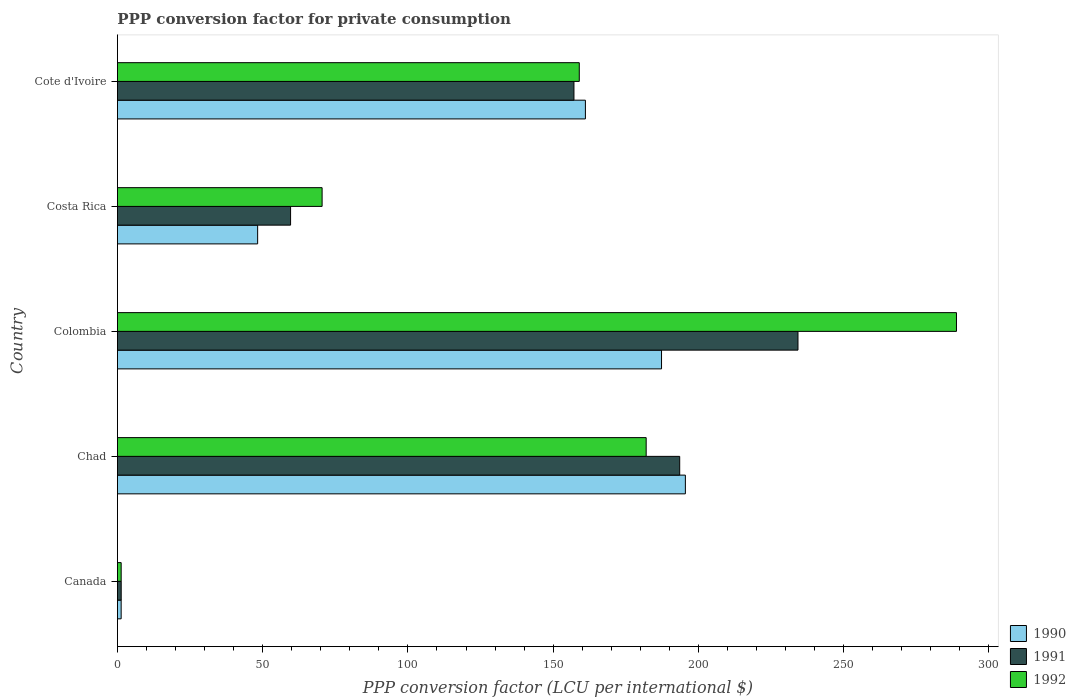How many different coloured bars are there?
Offer a terse response. 3. How many groups of bars are there?
Your response must be concise. 5. Are the number of bars per tick equal to the number of legend labels?
Offer a very short reply. Yes. Are the number of bars on each tick of the Y-axis equal?
Make the answer very short. Yes. How many bars are there on the 3rd tick from the top?
Make the answer very short. 3. What is the label of the 4th group of bars from the top?
Ensure brevity in your answer.  Chad. In how many cases, is the number of bars for a given country not equal to the number of legend labels?
Your response must be concise. 0. What is the PPP conversion factor for private consumption in 1990 in Costa Rica?
Your response must be concise. 48.27. Across all countries, what is the maximum PPP conversion factor for private consumption in 1990?
Offer a very short reply. 195.5. Across all countries, what is the minimum PPP conversion factor for private consumption in 1992?
Offer a very short reply. 1.3. In which country was the PPP conversion factor for private consumption in 1990 maximum?
Provide a short and direct response. Chad. What is the total PPP conversion factor for private consumption in 1990 in the graph?
Provide a short and direct response. 593.45. What is the difference between the PPP conversion factor for private consumption in 1992 in Canada and that in Costa Rica?
Give a very brief answer. -69.16. What is the difference between the PPP conversion factor for private consumption in 1992 in Costa Rica and the PPP conversion factor for private consumption in 1991 in Colombia?
Your response must be concise. -163.8. What is the average PPP conversion factor for private consumption in 1991 per country?
Your answer should be compact. 129.17. What is the difference between the PPP conversion factor for private consumption in 1991 and PPP conversion factor for private consumption in 1990 in Canada?
Your response must be concise. 0.02. In how many countries, is the PPP conversion factor for private consumption in 1991 greater than 130 LCU?
Provide a succinct answer. 3. What is the ratio of the PPP conversion factor for private consumption in 1992 in Chad to that in Colombia?
Offer a terse response. 0.63. What is the difference between the highest and the second highest PPP conversion factor for private consumption in 1991?
Provide a succinct answer. 40.71. What is the difference between the highest and the lowest PPP conversion factor for private consumption in 1992?
Provide a succinct answer. 287.52. In how many countries, is the PPP conversion factor for private consumption in 1991 greater than the average PPP conversion factor for private consumption in 1991 taken over all countries?
Your answer should be compact. 3. What does the 2nd bar from the top in Chad represents?
Offer a very short reply. 1991. What does the 3rd bar from the bottom in Canada represents?
Keep it short and to the point. 1992. Is it the case that in every country, the sum of the PPP conversion factor for private consumption in 1992 and PPP conversion factor for private consumption in 1990 is greater than the PPP conversion factor for private consumption in 1991?
Make the answer very short. Yes. What is the difference between two consecutive major ticks on the X-axis?
Provide a short and direct response. 50. Are the values on the major ticks of X-axis written in scientific E-notation?
Provide a succinct answer. No. Does the graph contain any zero values?
Your answer should be compact. No. How many legend labels are there?
Give a very brief answer. 3. What is the title of the graph?
Provide a succinct answer. PPP conversion factor for private consumption. What is the label or title of the X-axis?
Provide a short and direct response. PPP conversion factor (LCU per international $). What is the PPP conversion factor (LCU per international $) in 1990 in Canada?
Give a very brief answer. 1.29. What is the PPP conversion factor (LCU per international $) of 1991 in Canada?
Make the answer very short. 1.31. What is the PPP conversion factor (LCU per international $) in 1992 in Canada?
Provide a succinct answer. 1.3. What is the PPP conversion factor (LCU per international $) of 1990 in Chad?
Provide a short and direct response. 195.5. What is the PPP conversion factor (LCU per international $) of 1991 in Chad?
Offer a terse response. 193.55. What is the PPP conversion factor (LCU per international $) in 1992 in Chad?
Provide a short and direct response. 182.01. What is the PPP conversion factor (LCU per international $) in 1990 in Colombia?
Give a very brief answer. 187.29. What is the PPP conversion factor (LCU per international $) in 1991 in Colombia?
Your response must be concise. 234.26. What is the PPP conversion factor (LCU per international $) of 1992 in Colombia?
Offer a terse response. 288.82. What is the PPP conversion factor (LCU per international $) of 1990 in Costa Rica?
Make the answer very short. 48.27. What is the PPP conversion factor (LCU per international $) of 1991 in Costa Rica?
Offer a terse response. 59.61. What is the PPP conversion factor (LCU per international $) in 1992 in Costa Rica?
Offer a terse response. 70.46. What is the PPP conversion factor (LCU per international $) of 1990 in Cote d'Ivoire?
Provide a succinct answer. 161.09. What is the PPP conversion factor (LCU per international $) in 1991 in Cote d'Ivoire?
Offer a terse response. 157.15. What is the PPP conversion factor (LCU per international $) of 1992 in Cote d'Ivoire?
Provide a short and direct response. 158.98. Across all countries, what is the maximum PPP conversion factor (LCU per international $) in 1990?
Offer a very short reply. 195.5. Across all countries, what is the maximum PPP conversion factor (LCU per international $) in 1991?
Offer a terse response. 234.26. Across all countries, what is the maximum PPP conversion factor (LCU per international $) of 1992?
Keep it short and to the point. 288.82. Across all countries, what is the minimum PPP conversion factor (LCU per international $) of 1990?
Offer a very short reply. 1.29. Across all countries, what is the minimum PPP conversion factor (LCU per international $) in 1991?
Give a very brief answer. 1.31. Across all countries, what is the minimum PPP conversion factor (LCU per international $) in 1992?
Your answer should be very brief. 1.3. What is the total PPP conversion factor (LCU per international $) in 1990 in the graph?
Give a very brief answer. 593.45. What is the total PPP conversion factor (LCU per international $) of 1991 in the graph?
Your answer should be compact. 645.87. What is the total PPP conversion factor (LCU per international $) in 1992 in the graph?
Your answer should be compact. 701.56. What is the difference between the PPP conversion factor (LCU per international $) in 1990 in Canada and that in Chad?
Offer a terse response. -194.21. What is the difference between the PPP conversion factor (LCU per international $) in 1991 in Canada and that in Chad?
Your response must be concise. -192.24. What is the difference between the PPP conversion factor (LCU per international $) in 1992 in Canada and that in Chad?
Your answer should be compact. -180.71. What is the difference between the PPP conversion factor (LCU per international $) in 1990 in Canada and that in Colombia?
Your answer should be compact. -186. What is the difference between the PPP conversion factor (LCU per international $) in 1991 in Canada and that in Colombia?
Keep it short and to the point. -232.95. What is the difference between the PPP conversion factor (LCU per international $) in 1992 in Canada and that in Colombia?
Make the answer very short. -287.52. What is the difference between the PPP conversion factor (LCU per international $) in 1990 in Canada and that in Costa Rica?
Ensure brevity in your answer.  -46.98. What is the difference between the PPP conversion factor (LCU per international $) in 1991 in Canada and that in Costa Rica?
Keep it short and to the point. -58.3. What is the difference between the PPP conversion factor (LCU per international $) of 1992 in Canada and that in Costa Rica?
Your answer should be very brief. -69.16. What is the difference between the PPP conversion factor (LCU per international $) of 1990 in Canada and that in Cote d'Ivoire?
Offer a very short reply. -159.8. What is the difference between the PPP conversion factor (LCU per international $) in 1991 in Canada and that in Cote d'Ivoire?
Your response must be concise. -155.84. What is the difference between the PPP conversion factor (LCU per international $) of 1992 in Canada and that in Cote d'Ivoire?
Give a very brief answer. -157.69. What is the difference between the PPP conversion factor (LCU per international $) in 1990 in Chad and that in Colombia?
Your answer should be compact. 8.21. What is the difference between the PPP conversion factor (LCU per international $) of 1991 in Chad and that in Colombia?
Offer a terse response. -40.71. What is the difference between the PPP conversion factor (LCU per international $) of 1992 in Chad and that in Colombia?
Keep it short and to the point. -106.81. What is the difference between the PPP conversion factor (LCU per international $) of 1990 in Chad and that in Costa Rica?
Provide a short and direct response. 147.23. What is the difference between the PPP conversion factor (LCU per international $) in 1991 in Chad and that in Costa Rica?
Give a very brief answer. 133.94. What is the difference between the PPP conversion factor (LCU per international $) in 1992 in Chad and that in Costa Rica?
Make the answer very short. 111.55. What is the difference between the PPP conversion factor (LCU per international $) in 1990 in Chad and that in Cote d'Ivoire?
Your answer should be very brief. 34.41. What is the difference between the PPP conversion factor (LCU per international $) in 1991 in Chad and that in Cote d'Ivoire?
Provide a short and direct response. 36.4. What is the difference between the PPP conversion factor (LCU per international $) in 1992 in Chad and that in Cote d'Ivoire?
Provide a short and direct response. 23.03. What is the difference between the PPP conversion factor (LCU per international $) of 1990 in Colombia and that in Costa Rica?
Make the answer very short. 139.02. What is the difference between the PPP conversion factor (LCU per international $) in 1991 in Colombia and that in Costa Rica?
Offer a terse response. 174.65. What is the difference between the PPP conversion factor (LCU per international $) in 1992 in Colombia and that in Costa Rica?
Your response must be concise. 218.36. What is the difference between the PPP conversion factor (LCU per international $) in 1990 in Colombia and that in Cote d'Ivoire?
Offer a very short reply. 26.2. What is the difference between the PPP conversion factor (LCU per international $) in 1991 in Colombia and that in Cote d'Ivoire?
Your response must be concise. 77.11. What is the difference between the PPP conversion factor (LCU per international $) of 1992 in Colombia and that in Cote d'Ivoire?
Provide a short and direct response. 129.83. What is the difference between the PPP conversion factor (LCU per international $) of 1990 in Costa Rica and that in Cote d'Ivoire?
Your response must be concise. -112.82. What is the difference between the PPP conversion factor (LCU per international $) of 1991 in Costa Rica and that in Cote d'Ivoire?
Offer a very short reply. -97.54. What is the difference between the PPP conversion factor (LCU per international $) of 1992 in Costa Rica and that in Cote d'Ivoire?
Offer a very short reply. -88.52. What is the difference between the PPP conversion factor (LCU per international $) of 1990 in Canada and the PPP conversion factor (LCU per international $) of 1991 in Chad?
Offer a terse response. -192.26. What is the difference between the PPP conversion factor (LCU per international $) of 1990 in Canada and the PPP conversion factor (LCU per international $) of 1992 in Chad?
Your response must be concise. -180.72. What is the difference between the PPP conversion factor (LCU per international $) in 1991 in Canada and the PPP conversion factor (LCU per international $) in 1992 in Chad?
Provide a short and direct response. -180.7. What is the difference between the PPP conversion factor (LCU per international $) of 1990 in Canada and the PPP conversion factor (LCU per international $) of 1991 in Colombia?
Give a very brief answer. -232.97. What is the difference between the PPP conversion factor (LCU per international $) of 1990 in Canada and the PPP conversion factor (LCU per international $) of 1992 in Colombia?
Offer a terse response. -287.52. What is the difference between the PPP conversion factor (LCU per international $) of 1991 in Canada and the PPP conversion factor (LCU per international $) of 1992 in Colombia?
Your answer should be very brief. -287.51. What is the difference between the PPP conversion factor (LCU per international $) of 1990 in Canada and the PPP conversion factor (LCU per international $) of 1991 in Costa Rica?
Make the answer very short. -58.32. What is the difference between the PPP conversion factor (LCU per international $) of 1990 in Canada and the PPP conversion factor (LCU per international $) of 1992 in Costa Rica?
Your answer should be compact. -69.17. What is the difference between the PPP conversion factor (LCU per international $) in 1991 in Canada and the PPP conversion factor (LCU per international $) in 1992 in Costa Rica?
Provide a succinct answer. -69.15. What is the difference between the PPP conversion factor (LCU per international $) in 1990 in Canada and the PPP conversion factor (LCU per international $) in 1991 in Cote d'Ivoire?
Your answer should be compact. -155.86. What is the difference between the PPP conversion factor (LCU per international $) of 1990 in Canada and the PPP conversion factor (LCU per international $) of 1992 in Cote d'Ivoire?
Offer a very short reply. -157.69. What is the difference between the PPP conversion factor (LCU per international $) in 1991 in Canada and the PPP conversion factor (LCU per international $) in 1992 in Cote d'Ivoire?
Give a very brief answer. -157.67. What is the difference between the PPP conversion factor (LCU per international $) in 1990 in Chad and the PPP conversion factor (LCU per international $) in 1991 in Colombia?
Provide a succinct answer. -38.76. What is the difference between the PPP conversion factor (LCU per international $) of 1990 in Chad and the PPP conversion factor (LCU per international $) of 1992 in Colombia?
Offer a very short reply. -93.32. What is the difference between the PPP conversion factor (LCU per international $) of 1991 in Chad and the PPP conversion factor (LCU per international $) of 1992 in Colombia?
Your answer should be very brief. -95.27. What is the difference between the PPP conversion factor (LCU per international $) of 1990 in Chad and the PPP conversion factor (LCU per international $) of 1991 in Costa Rica?
Offer a terse response. 135.89. What is the difference between the PPP conversion factor (LCU per international $) in 1990 in Chad and the PPP conversion factor (LCU per international $) in 1992 in Costa Rica?
Provide a short and direct response. 125.04. What is the difference between the PPP conversion factor (LCU per international $) of 1991 in Chad and the PPP conversion factor (LCU per international $) of 1992 in Costa Rica?
Provide a short and direct response. 123.09. What is the difference between the PPP conversion factor (LCU per international $) in 1990 in Chad and the PPP conversion factor (LCU per international $) in 1991 in Cote d'Ivoire?
Your answer should be very brief. 38.35. What is the difference between the PPP conversion factor (LCU per international $) of 1990 in Chad and the PPP conversion factor (LCU per international $) of 1992 in Cote d'Ivoire?
Give a very brief answer. 36.52. What is the difference between the PPP conversion factor (LCU per international $) of 1991 in Chad and the PPP conversion factor (LCU per international $) of 1992 in Cote d'Ivoire?
Your response must be concise. 34.56. What is the difference between the PPP conversion factor (LCU per international $) of 1990 in Colombia and the PPP conversion factor (LCU per international $) of 1991 in Costa Rica?
Provide a succinct answer. 127.69. What is the difference between the PPP conversion factor (LCU per international $) in 1990 in Colombia and the PPP conversion factor (LCU per international $) in 1992 in Costa Rica?
Your response must be concise. 116.83. What is the difference between the PPP conversion factor (LCU per international $) of 1991 in Colombia and the PPP conversion factor (LCU per international $) of 1992 in Costa Rica?
Give a very brief answer. 163.8. What is the difference between the PPP conversion factor (LCU per international $) in 1990 in Colombia and the PPP conversion factor (LCU per international $) in 1991 in Cote d'Ivoire?
Offer a terse response. 30.15. What is the difference between the PPP conversion factor (LCU per international $) of 1990 in Colombia and the PPP conversion factor (LCU per international $) of 1992 in Cote d'Ivoire?
Keep it short and to the point. 28.31. What is the difference between the PPP conversion factor (LCU per international $) of 1991 in Colombia and the PPP conversion factor (LCU per international $) of 1992 in Cote d'Ivoire?
Keep it short and to the point. 75.28. What is the difference between the PPP conversion factor (LCU per international $) in 1990 in Costa Rica and the PPP conversion factor (LCU per international $) in 1991 in Cote d'Ivoire?
Offer a terse response. -108.88. What is the difference between the PPP conversion factor (LCU per international $) of 1990 in Costa Rica and the PPP conversion factor (LCU per international $) of 1992 in Cote d'Ivoire?
Offer a terse response. -110.71. What is the difference between the PPP conversion factor (LCU per international $) in 1991 in Costa Rica and the PPP conversion factor (LCU per international $) in 1992 in Cote d'Ivoire?
Your answer should be compact. -99.38. What is the average PPP conversion factor (LCU per international $) of 1990 per country?
Give a very brief answer. 118.69. What is the average PPP conversion factor (LCU per international $) of 1991 per country?
Your answer should be very brief. 129.17. What is the average PPP conversion factor (LCU per international $) in 1992 per country?
Keep it short and to the point. 140.31. What is the difference between the PPP conversion factor (LCU per international $) of 1990 and PPP conversion factor (LCU per international $) of 1991 in Canada?
Provide a succinct answer. -0.02. What is the difference between the PPP conversion factor (LCU per international $) in 1990 and PPP conversion factor (LCU per international $) in 1992 in Canada?
Ensure brevity in your answer.  -0.01. What is the difference between the PPP conversion factor (LCU per international $) of 1991 and PPP conversion factor (LCU per international $) of 1992 in Canada?
Give a very brief answer. 0.01. What is the difference between the PPP conversion factor (LCU per international $) in 1990 and PPP conversion factor (LCU per international $) in 1991 in Chad?
Provide a succinct answer. 1.95. What is the difference between the PPP conversion factor (LCU per international $) of 1990 and PPP conversion factor (LCU per international $) of 1992 in Chad?
Your response must be concise. 13.49. What is the difference between the PPP conversion factor (LCU per international $) in 1991 and PPP conversion factor (LCU per international $) in 1992 in Chad?
Keep it short and to the point. 11.54. What is the difference between the PPP conversion factor (LCU per international $) in 1990 and PPP conversion factor (LCU per international $) in 1991 in Colombia?
Offer a terse response. -46.97. What is the difference between the PPP conversion factor (LCU per international $) in 1990 and PPP conversion factor (LCU per international $) in 1992 in Colombia?
Your response must be concise. -101.52. What is the difference between the PPP conversion factor (LCU per international $) of 1991 and PPP conversion factor (LCU per international $) of 1992 in Colombia?
Keep it short and to the point. -54.56. What is the difference between the PPP conversion factor (LCU per international $) in 1990 and PPP conversion factor (LCU per international $) in 1991 in Costa Rica?
Offer a terse response. -11.33. What is the difference between the PPP conversion factor (LCU per international $) of 1990 and PPP conversion factor (LCU per international $) of 1992 in Costa Rica?
Offer a very short reply. -22.19. What is the difference between the PPP conversion factor (LCU per international $) in 1991 and PPP conversion factor (LCU per international $) in 1992 in Costa Rica?
Provide a short and direct response. -10.85. What is the difference between the PPP conversion factor (LCU per international $) of 1990 and PPP conversion factor (LCU per international $) of 1991 in Cote d'Ivoire?
Offer a very short reply. 3.94. What is the difference between the PPP conversion factor (LCU per international $) in 1990 and PPP conversion factor (LCU per international $) in 1992 in Cote d'Ivoire?
Your response must be concise. 2.11. What is the difference between the PPP conversion factor (LCU per international $) in 1991 and PPP conversion factor (LCU per international $) in 1992 in Cote d'Ivoire?
Your response must be concise. -1.83. What is the ratio of the PPP conversion factor (LCU per international $) of 1990 in Canada to that in Chad?
Keep it short and to the point. 0.01. What is the ratio of the PPP conversion factor (LCU per international $) of 1991 in Canada to that in Chad?
Keep it short and to the point. 0.01. What is the ratio of the PPP conversion factor (LCU per international $) in 1992 in Canada to that in Chad?
Give a very brief answer. 0.01. What is the ratio of the PPP conversion factor (LCU per international $) of 1990 in Canada to that in Colombia?
Your response must be concise. 0.01. What is the ratio of the PPP conversion factor (LCU per international $) in 1991 in Canada to that in Colombia?
Provide a short and direct response. 0.01. What is the ratio of the PPP conversion factor (LCU per international $) in 1992 in Canada to that in Colombia?
Ensure brevity in your answer.  0. What is the ratio of the PPP conversion factor (LCU per international $) in 1990 in Canada to that in Costa Rica?
Give a very brief answer. 0.03. What is the ratio of the PPP conversion factor (LCU per international $) of 1991 in Canada to that in Costa Rica?
Provide a short and direct response. 0.02. What is the ratio of the PPP conversion factor (LCU per international $) in 1992 in Canada to that in Costa Rica?
Provide a succinct answer. 0.02. What is the ratio of the PPP conversion factor (LCU per international $) in 1990 in Canada to that in Cote d'Ivoire?
Your response must be concise. 0.01. What is the ratio of the PPP conversion factor (LCU per international $) of 1991 in Canada to that in Cote d'Ivoire?
Make the answer very short. 0.01. What is the ratio of the PPP conversion factor (LCU per international $) of 1992 in Canada to that in Cote d'Ivoire?
Ensure brevity in your answer.  0.01. What is the ratio of the PPP conversion factor (LCU per international $) of 1990 in Chad to that in Colombia?
Your answer should be compact. 1.04. What is the ratio of the PPP conversion factor (LCU per international $) of 1991 in Chad to that in Colombia?
Provide a succinct answer. 0.83. What is the ratio of the PPP conversion factor (LCU per international $) of 1992 in Chad to that in Colombia?
Provide a short and direct response. 0.63. What is the ratio of the PPP conversion factor (LCU per international $) in 1990 in Chad to that in Costa Rica?
Give a very brief answer. 4.05. What is the ratio of the PPP conversion factor (LCU per international $) of 1991 in Chad to that in Costa Rica?
Provide a short and direct response. 3.25. What is the ratio of the PPP conversion factor (LCU per international $) in 1992 in Chad to that in Costa Rica?
Offer a very short reply. 2.58. What is the ratio of the PPP conversion factor (LCU per international $) in 1990 in Chad to that in Cote d'Ivoire?
Provide a succinct answer. 1.21. What is the ratio of the PPP conversion factor (LCU per international $) in 1991 in Chad to that in Cote d'Ivoire?
Offer a very short reply. 1.23. What is the ratio of the PPP conversion factor (LCU per international $) in 1992 in Chad to that in Cote d'Ivoire?
Offer a very short reply. 1.14. What is the ratio of the PPP conversion factor (LCU per international $) of 1990 in Colombia to that in Costa Rica?
Your answer should be compact. 3.88. What is the ratio of the PPP conversion factor (LCU per international $) in 1991 in Colombia to that in Costa Rica?
Your answer should be compact. 3.93. What is the ratio of the PPP conversion factor (LCU per international $) in 1992 in Colombia to that in Costa Rica?
Your answer should be very brief. 4.1. What is the ratio of the PPP conversion factor (LCU per international $) in 1990 in Colombia to that in Cote d'Ivoire?
Give a very brief answer. 1.16. What is the ratio of the PPP conversion factor (LCU per international $) in 1991 in Colombia to that in Cote d'Ivoire?
Your response must be concise. 1.49. What is the ratio of the PPP conversion factor (LCU per international $) in 1992 in Colombia to that in Cote d'Ivoire?
Provide a succinct answer. 1.82. What is the ratio of the PPP conversion factor (LCU per international $) in 1990 in Costa Rica to that in Cote d'Ivoire?
Keep it short and to the point. 0.3. What is the ratio of the PPP conversion factor (LCU per international $) of 1991 in Costa Rica to that in Cote d'Ivoire?
Provide a short and direct response. 0.38. What is the ratio of the PPP conversion factor (LCU per international $) of 1992 in Costa Rica to that in Cote d'Ivoire?
Keep it short and to the point. 0.44. What is the difference between the highest and the second highest PPP conversion factor (LCU per international $) in 1990?
Provide a short and direct response. 8.21. What is the difference between the highest and the second highest PPP conversion factor (LCU per international $) of 1991?
Your answer should be very brief. 40.71. What is the difference between the highest and the second highest PPP conversion factor (LCU per international $) of 1992?
Your answer should be very brief. 106.81. What is the difference between the highest and the lowest PPP conversion factor (LCU per international $) of 1990?
Offer a very short reply. 194.21. What is the difference between the highest and the lowest PPP conversion factor (LCU per international $) in 1991?
Offer a terse response. 232.95. What is the difference between the highest and the lowest PPP conversion factor (LCU per international $) of 1992?
Ensure brevity in your answer.  287.52. 